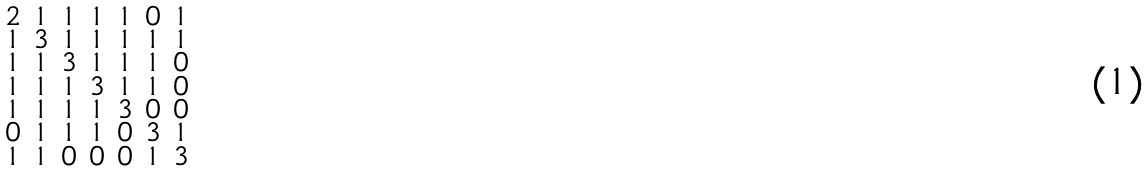Convert formula to latex. <formula><loc_0><loc_0><loc_500><loc_500>\begin{smallmatrix} 2 & 1 & 1 & 1 & 1 & 0 & 1 \\ 1 & 3 & 1 & 1 & 1 & 1 & 1 \\ 1 & 1 & 3 & 1 & 1 & 1 & 0 \\ 1 & 1 & 1 & 3 & 1 & 1 & 0 \\ 1 & 1 & 1 & 1 & 3 & 0 & 0 \\ 0 & 1 & 1 & 1 & 0 & 3 & 1 \\ 1 & 1 & 0 & 0 & 0 & 1 & 3 \end{smallmatrix}</formula> 